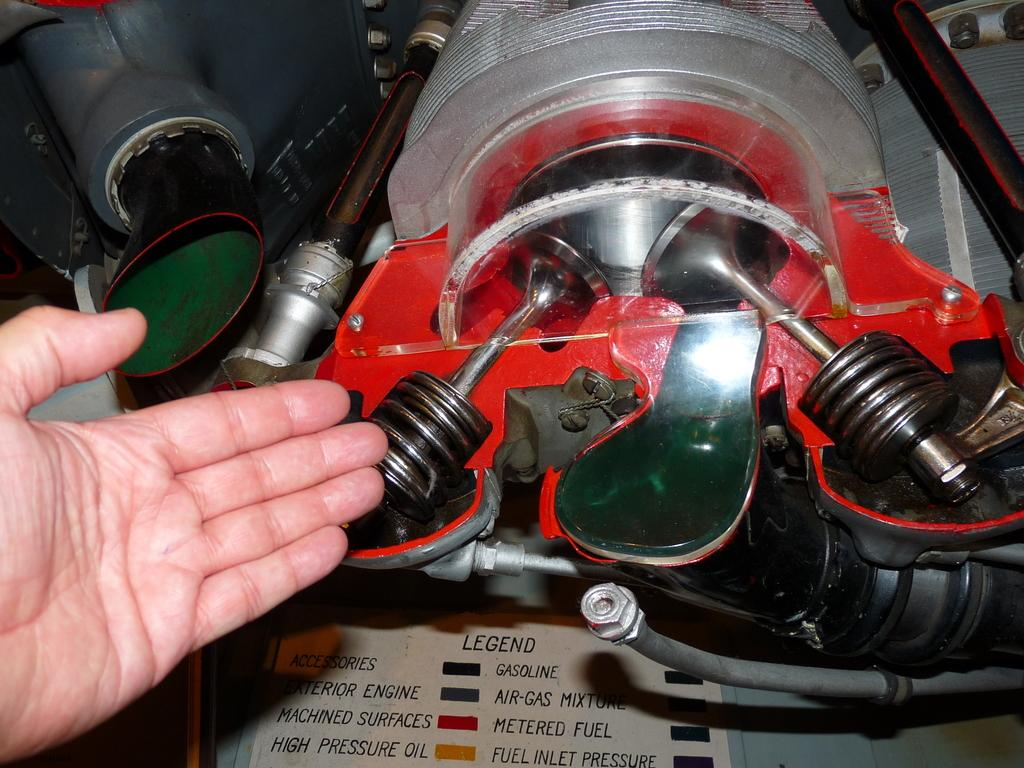What is the main subject in the center of the image? There is an engine in the center of the image. Can you describe any other elements in the image? Yes, there is a person's hand visible in the image. What type of mountain can be seen in the background of the image? There is no mountain visible in the image; it only features an engine and a person's hand. What color is the underwear worn by the person in the image? There is no underwear visible in the image, as only a person's hand is present. 